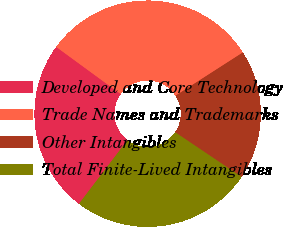Convert chart. <chart><loc_0><loc_0><loc_500><loc_500><pie_chart><fcel>Developed and Core Technology<fcel>Trade Names and Trademarks<fcel>Other Intangibles<fcel>Total Finite-Lived Intangibles<nl><fcel>24.69%<fcel>30.86%<fcel>18.52%<fcel>25.93%<nl></chart> 